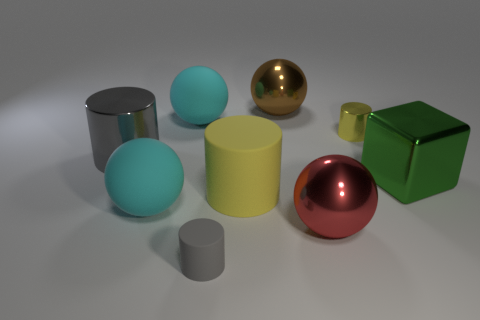Are any big cylinders visible?
Keep it short and to the point. Yes. What is the yellow cylinder that is on the left side of the shiny ball in front of the large matte thing behind the yellow matte thing made of?
Offer a very short reply. Rubber. Is the number of large gray metal objects that are right of the big yellow cylinder less than the number of big yellow metal cubes?
Offer a very short reply. No. There is a yellow cylinder that is the same size as the brown sphere; what is it made of?
Offer a very short reply. Rubber. There is a cylinder that is both behind the large yellow thing and on the right side of the gray matte object; how big is it?
Provide a succinct answer. Small. There is a gray metallic object that is the same shape as the yellow rubber object; what size is it?
Keep it short and to the point. Large. What number of things are either tiny yellow cylinders or metal spheres in front of the tiny yellow shiny cylinder?
Your response must be concise. 2. There is a big brown shiny thing; what shape is it?
Give a very brief answer. Sphere. What is the shape of the cyan object that is to the left of the large cyan sphere that is behind the green cube?
Ensure brevity in your answer.  Sphere. There is a large cylinder that is the same color as the tiny rubber thing; what is it made of?
Offer a terse response. Metal. 